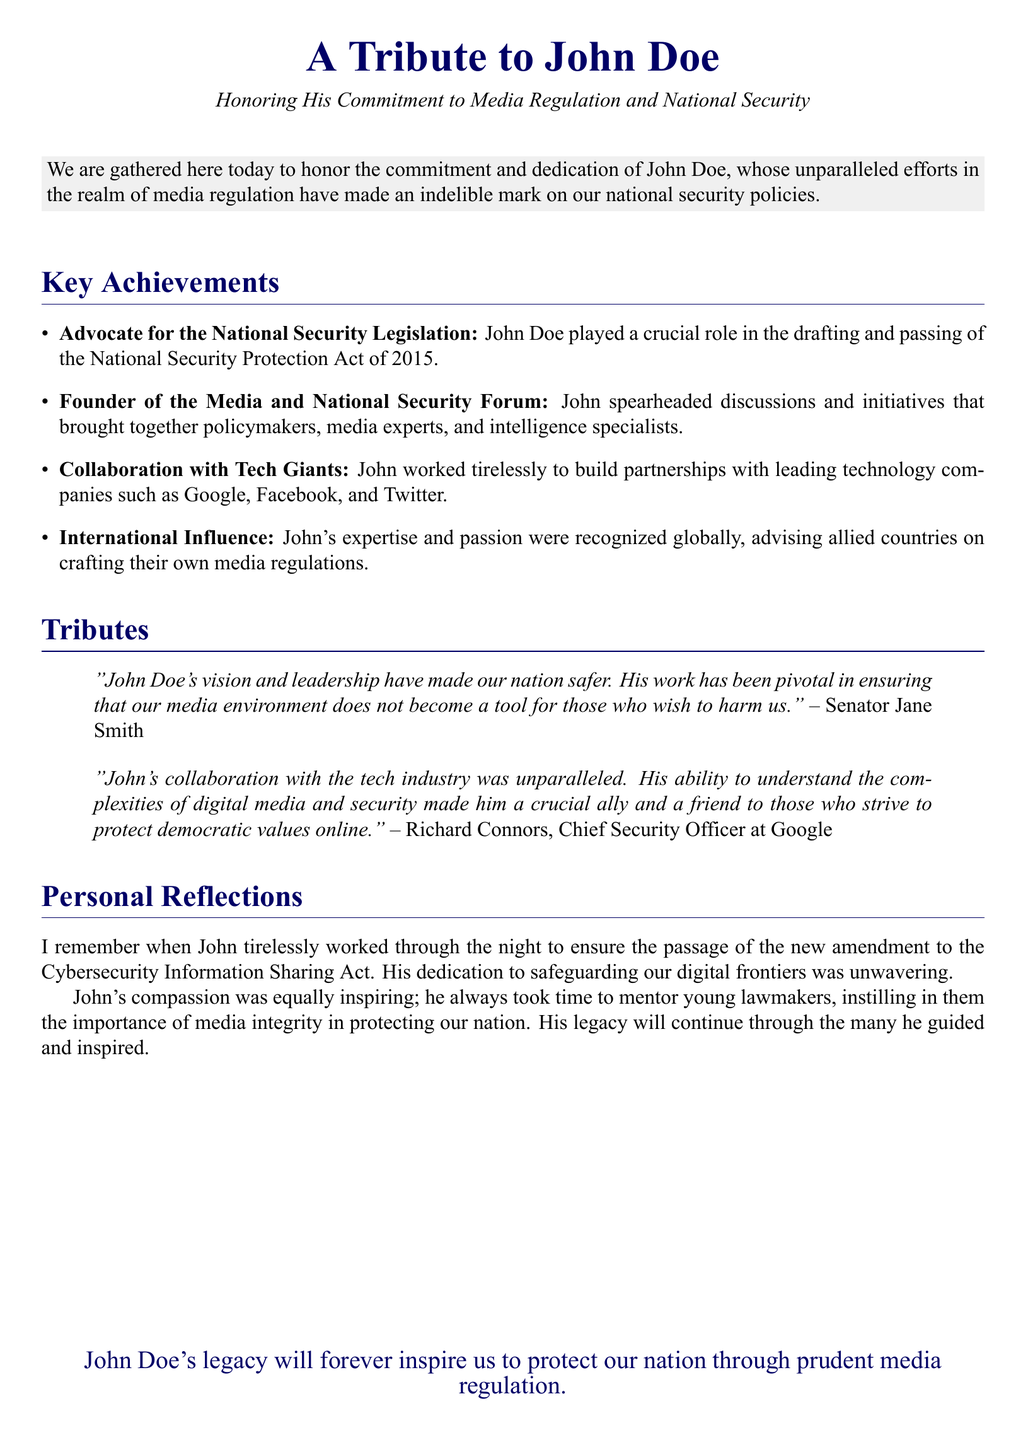What role did John Doe play in the National Security Protection Act? John Doe played a crucial role in the drafting and passing of the National Security Protection Act of 2015.
Answer: crucial role What organization did John Doe found? John founded the Media and National Security Forum, focusing on discussions and initiatives related to media and security.
Answer: Media and National Security Forum Who recognized John Doe's expertise globally? John's expertise and passion were recognized globally, advising allied countries on crafting their own media regulations.
Answer: allied countries How did John Doe collaborate with technology companies? John worked tirelessly to build partnerships with leading technology companies such as Google, Facebook, and Twitter.
Answer: partnerships What was a significant personal reflection mentioned about John? The personal reflection noted John's dedication to safeguarding digital frontiers through tireless work on legislation.
Answer: tireless work What year was the National Security Protection Act passed? The document states that the National Security Protection Act was passed in 2015.
Answer: 2015 Who is quoted in the document praising John Doe? Senator Jane Smith is quoted in the document praising John Doe's vision and leadership.
Answer: Senator Jane Smith What was John Doe's impact on young lawmakers? John instilled in young lawmakers the importance of media integrity in protecting the nation.
Answer: importance of media integrity What final sentiment is expressed about John Doe's legacy? The document concludes that John Doe's legacy will inspire us to protect our nation through prudent media regulation.
Answer: prudent media regulation 